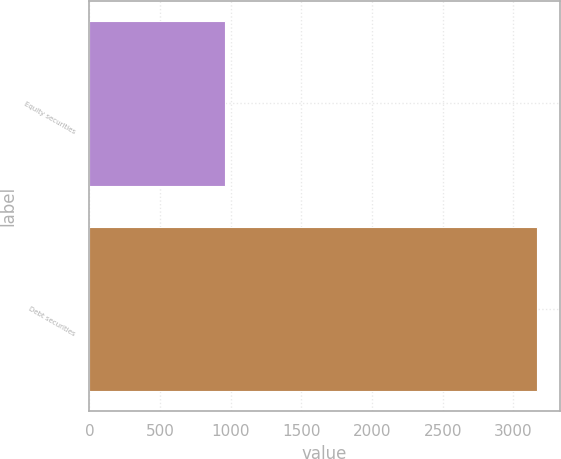Convert chart. <chart><loc_0><loc_0><loc_500><loc_500><bar_chart><fcel>Equity securities<fcel>Debt securities<nl><fcel>957<fcel>3169<nl></chart> 